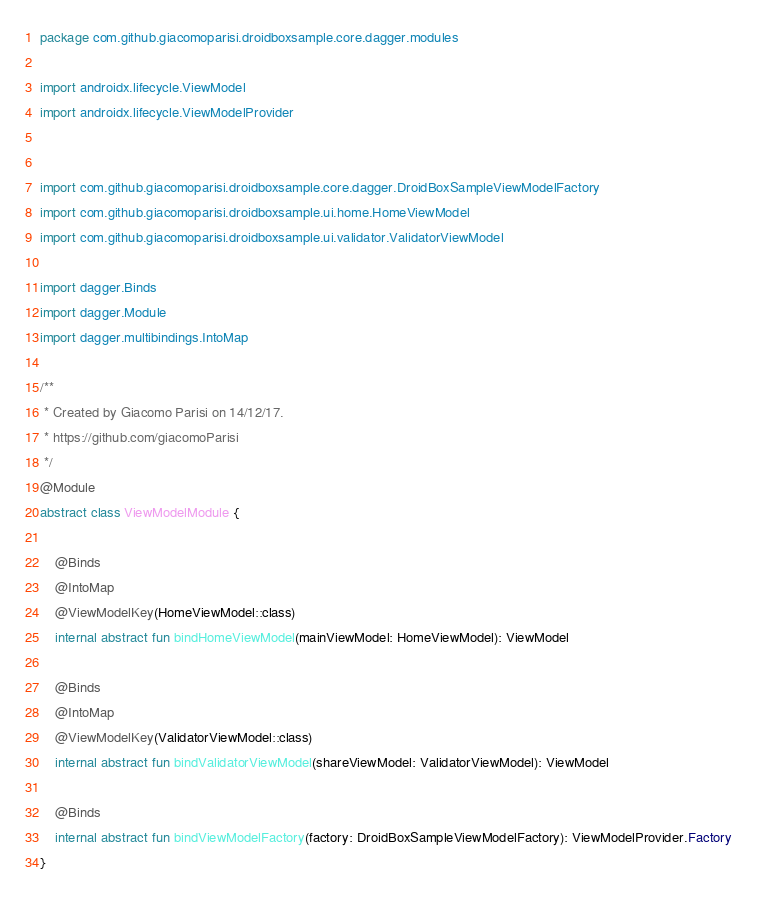<code> <loc_0><loc_0><loc_500><loc_500><_Kotlin_>package com.github.giacomoparisi.droidboxsample.core.dagger.modules

import androidx.lifecycle.ViewModel
import androidx.lifecycle.ViewModelProvider


import com.github.giacomoparisi.droidboxsample.core.dagger.DroidBoxSampleViewModelFactory
import com.github.giacomoparisi.droidboxsample.ui.home.HomeViewModel
import com.github.giacomoparisi.droidboxsample.ui.validator.ValidatorViewModel

import dagger.Binds
import dagger.Module
import dagger.multibindings.IntoMap

/**
 * Created by Giacomo Parisi on 14/12/17.
 * https://github.com/giacomoParisi
 */
@Module
abstract class ViewModelModule {

    @Binds
    @IntoMap
    @ViewModelKey(HomeViewModel::class)
    internal abstract fun bindHomeViewModel(mainViewModel: HomeViewModel): ViewModel

    @Binds
    @IntoMap
    @ViewModelKey(ValidatorViewModel::class)
    internal abstract fun bindValidatorViewModel(shareViewModel: ValidatorViewModel): ViewModel

    @Binds
    internal abstract fun bindViewModelFactory(factory: DroidBoxSampleViewModelFactory): ViewModelProvider.Factory
}
</code> 